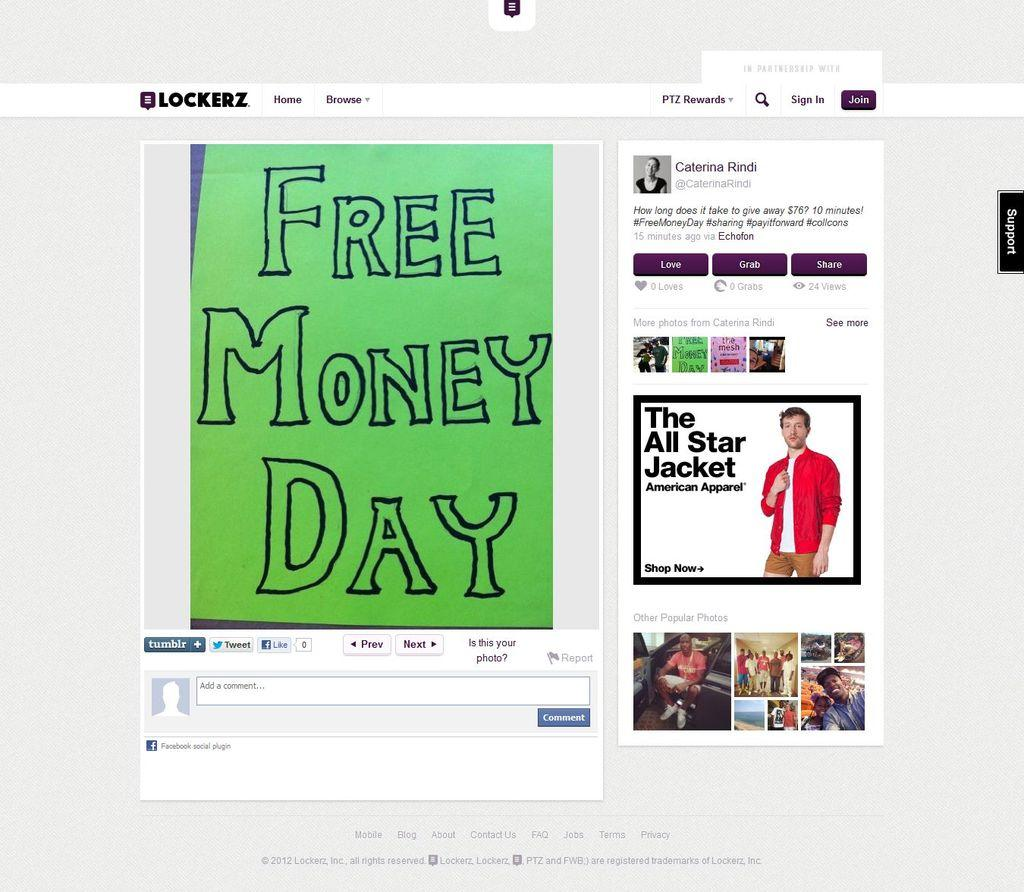<image>
Relay a brief, clear account of the picture shown. A Blockerz website page shows a sign for free money day. 